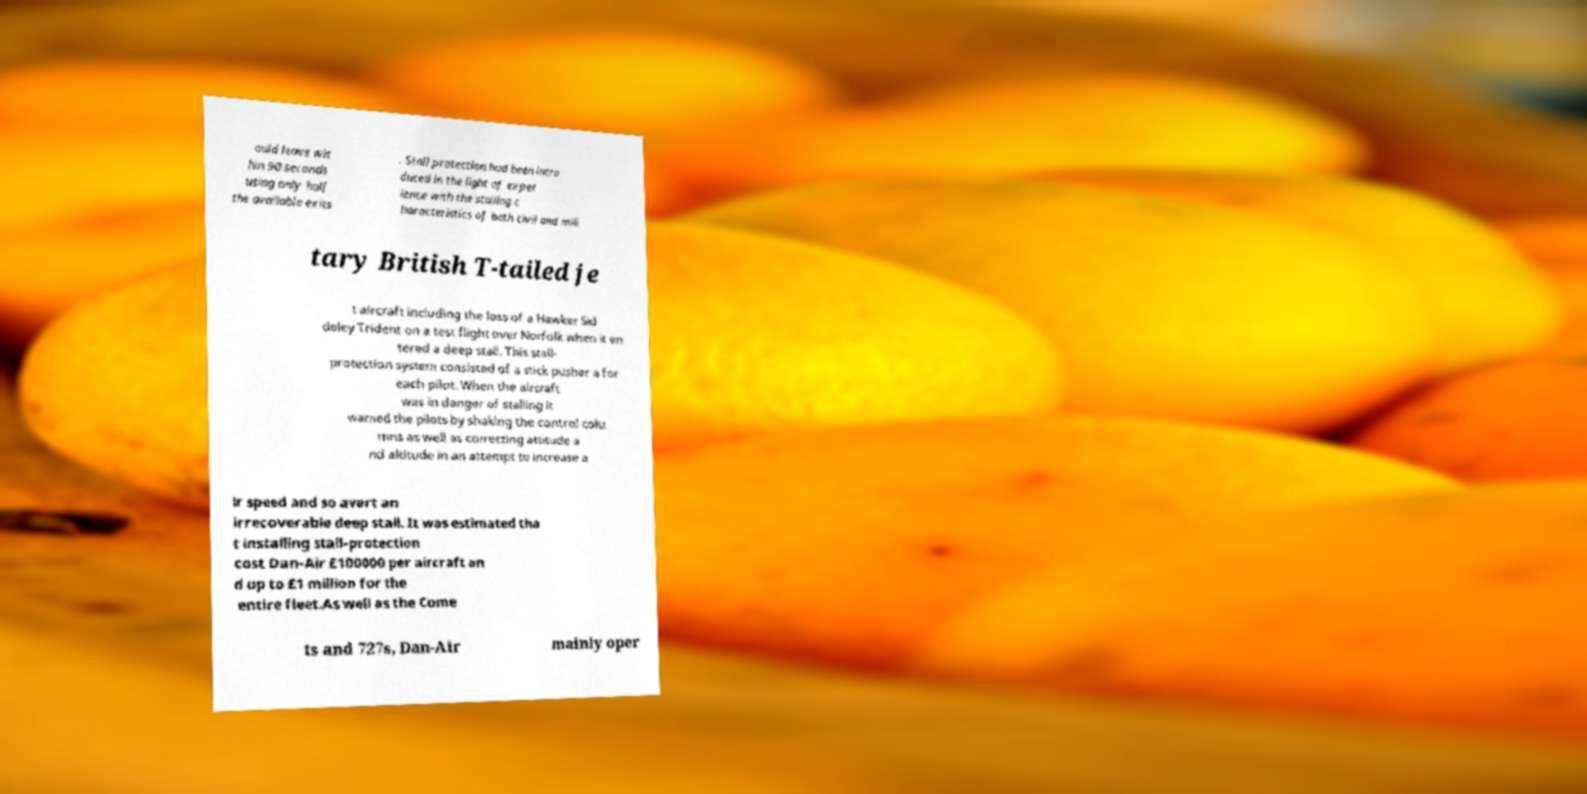Please read and relay the text visible in this image. What does it say? ould leave wit hin 90 seconds using only half the available exits . Stall protection had been intro duced in the light of exper ience with the stalling c haracteristics of both civil and mili tary British T-tailed je t aircraft including the loss of a Hawker Sid deley Trident on a test flight over Norfolk when it en tered a deep stall. This stall- protection system consisted of a stick pusher a for each pilot. When the aircraft was in danger of stalling it warned the pilots by shaking the control colu mns as well as correcting attitude a nd altitude in an attempt to increase a ir speed and so avert an irrecoverable deep stall. It was estimated tha t installing stall-protection cost Dan-Air £100000 per aircraft an d up to £1 million for the entire fleet.As well as the Come ts and 727s, Dan-Air mainly oper 